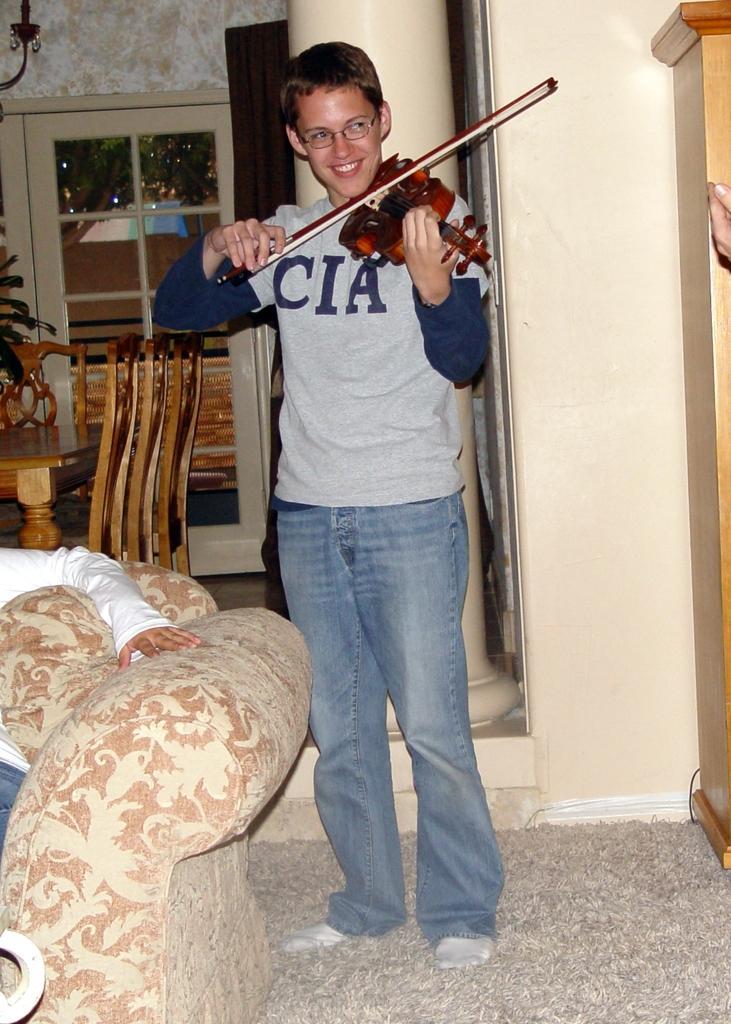Could you give a brief overview of what you see in this image? In this image there is a boy smiling and playing violin. Beside to him there is a person sitting on sofa. At right side there is a cabinet and back side of sofa there is a dining table and two chairs. At the background there is a window and lamp. 